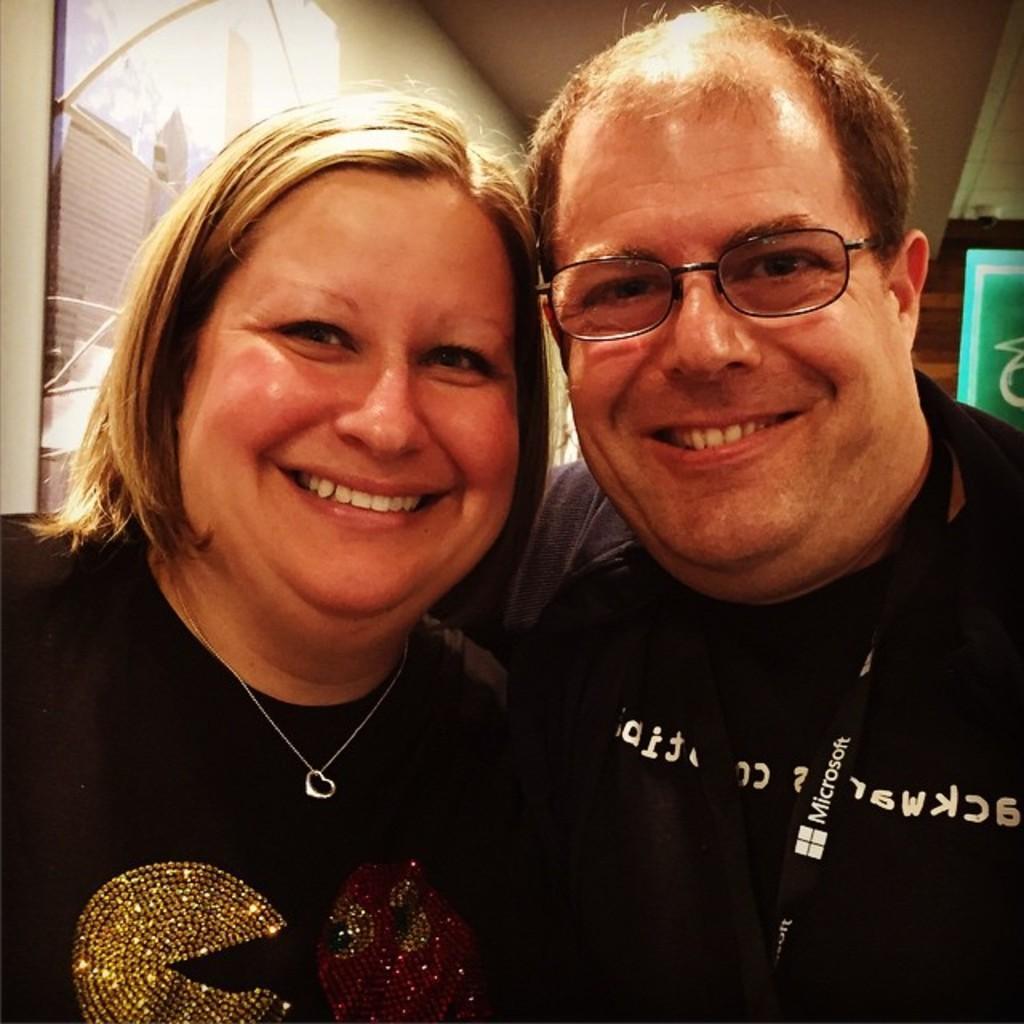How would you summarize this image in a sentence or two? In this image there is a man and woman standing, in the background there is a wall. 